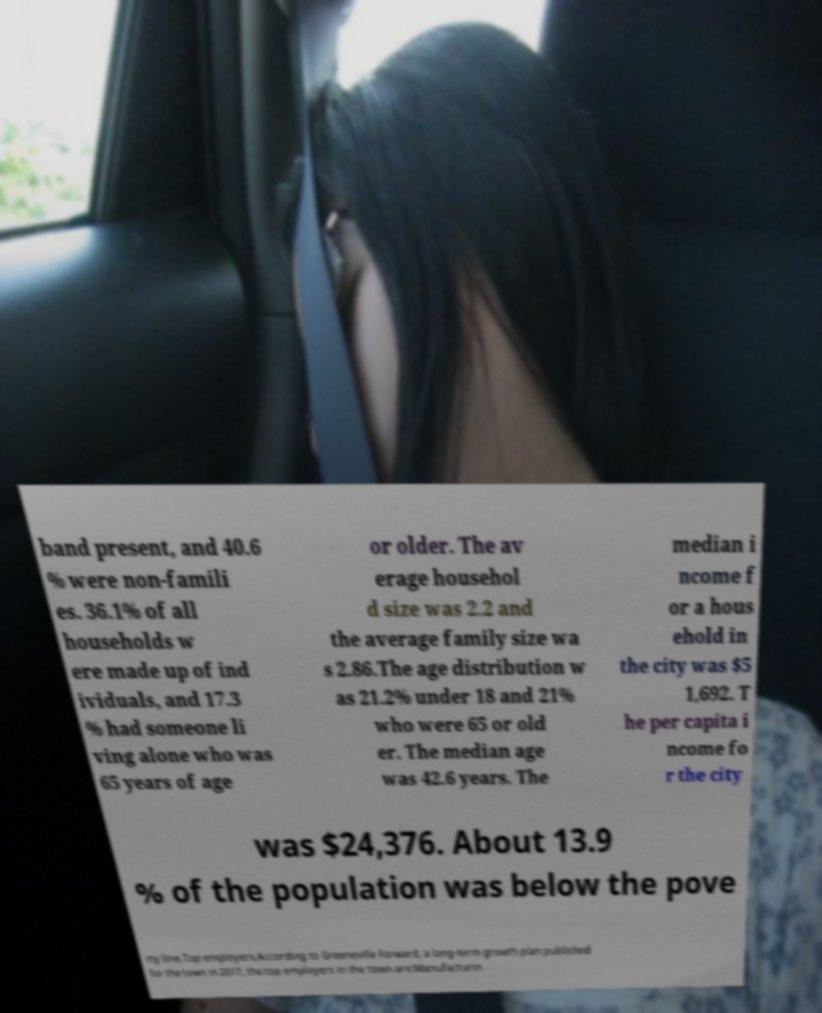I need the written content from this picture converted into text. Can you do that? band present, and 40.6 % were non-famili es. 36.1% of all households w ere made up of ind ividuals, and 17.3 % had someone li ving alone who was 65 years of age or older. The av erage househol d size was 2.2 and the average family size wa s 2.86.The age distribution w as 21.2% under 18 and 21% who were 65 or old er. The median age was 42.6 years. The median i ncome f or a hous ehold in the city was $5 1,692. T he per capita i ncome fo r the city was $24,376. About 13.9 % of the population was below the pove rty line.Top employers.According to Greeneville Forward, a long-term growth plan published for the town in 2017, the top employers in the town are:Manufacturin 